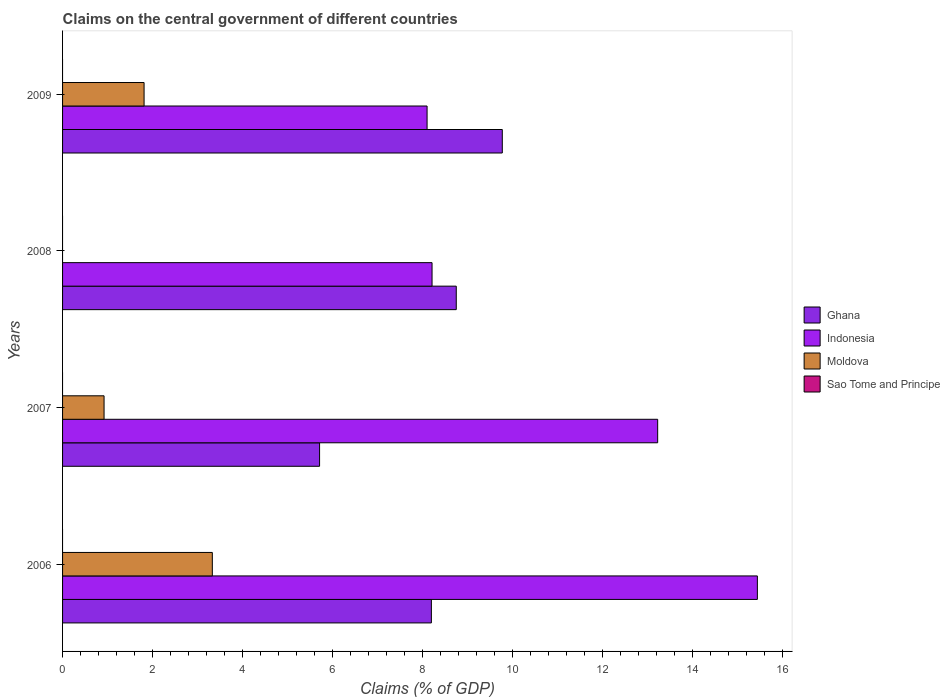How many different coloured bars are there?
Offer a very short reply. 3. How many groups of bars are there?
Your response must be concise. 4. Are the number of bars per tick equal to the number of legend labels?
Make the answer very short. No. Are the number of bars on each tick of the Y-axis equal?
Provide a short and direct response. No. How many bars are there on the 4th tick from the bottom?
Make the answer very short. 3. In how many cases, is the number of bars for a given year not equal to the number of legend labels?
Ensure brevity in your answer.  4. What is the percentage of GDP claimed on the central government in Indonesia in 2007?
Provide a succinct answer. 13.23. Across all years, what is the maximum percentage of GDP claimed on the central government in Indonesia?
Offer a terse response. 15.44. Across all years, what is the minimum percentage of GDP claimed on the central government in Ghana?
Give a very brief answer. 5.71. In which year was the percentage of GDP claimed on the central government in Moldova maximum?
Make the answer very short. 2006. What is the total percentage of GDP claimed on the central government in Indonesia in the graph?
Make the answer very short. 44.98. What is the difference between the percentage of GDP claimed on the central government in Indonesia in 2006 and that in 2007?
Your answer should be compact. 2.22. What is the difference between the percentage of GDP claimed on the central government in Indonesia in 2006 and the percentage of GDP claimed on the central government in Moldova in 2008?
Give a very brief answer. 15.44. In the year 2006, what is the difference between the percentage of GDP claimed on the central government in Ghana and percentage of GDP claimed on the central government in Moldova?
Offer a very short reply. 4.87. What is the ratio of the percentage of GDP claimed on the central government in Indonesia in 2006 to that in 2007?
Give a very brief answer. 1.17. Is the percentage of GDP claimed on the central government in Indonesia in 2006 less than that in 2007?
Your response must be concise. No. What is the difference between the highest and the second highest percentage of GDP claimed on the central government in Indonesia?
Offer a terse response. 2.22. What is the difference between the highest and the lowest percentage of GDP claimed on the central government in Ghana?
Provide a short and direct response. 4.06. Is it the case that in every year, the sum of the percentage of GDP claimed on the central government in Indonesia and percentage of GDP claimed on the central government in Sao Tome and Principe is greater than the sum of percentage of GDP claimed on the central government in Moldova and percentage of GDP claimed on the central government in Ghana?
Ensure brevity in your answer.  Yes. How many bars are there?
Make the answer very short. 11. Are all the bars in the graph horizontal?
Your response must be concise. Yes. How many years are there in the graph?
Your response must be concise. 4. Does the graph contain grids?
Offer a very short reply. No. Where does the legend appear in the graph?
Offer a terse response. Center right. How many legend labels are there?
Keep it short and to the point. 4. What is the title of the graph?
Give a very brief answer. Claims on the central government of different countries. Does "Yemen, Rep." appear as one of the legend labels in the graph?
Give a very brief answer. No. What is the label or title of the X-axis?
Your answer should be compact. Claims (% of GDP). What is the label or title of the Y-axis?
Your answer should be compact. Years. What is the Claims (% of GDP) of Ghana in 2006?
Give a very brief answer. 8.2. What is the Claims (% of GDP) in Indonesia in 2006?
Give a very brief answer. 15.44. What is the Claims (% of GDP) of Moldova in 2006?
Give a very brief answer. 3.33. What is the Claims (% of GDP) of Ghana in 2007?
Give a very brief answer. 5.71. What is the Claims (% of GDP) of Indonesia in 2007?
Your answer should be compact. 13.23. What is the Claims (% of GDP) of Moldova in 2007?
Ensure brevity in your answer.  0.92. What is the Claims (% of GDP) of Sao Tome and Principe in 2007?
Your answer should be very brief. 0. What is the Claims (% of GDP) of Ghana in 2008?
Make the answer very short. 8.75. What is the Claims (% of GDP) of Indonesia in 2008?
Give a very brief answer. 8.21. What is the Claims (% of GDP) of Moldova in 2008?
Provide a succinct answer. 0. What is the Claims (% of GDP) of Ghana in 2009?
Keep it short and to the point. 9.77. What is the Claims (% of GDP) of Indonesia in 2009?
Your answer should be very brief. 8.1. What is the Claims (% of GDP) of Moldova in 2009?
Your response must be concise. 1.81. What is the Claims (% of GDP) in Sao Tome and Principe in 2009?
Your answer should be very brief. 0. Across all years, what is the maximum Claims (% of GDP) of Ghana?
Offer a very short reply. 9.77. Across all years, what is the maximum Claims (% of GDP) in Indonesia?
Your response must be concise. 15.44. Across all years, what is the maximum Claims (% of GDP) of Moldova?
Provide a succinct answer. 3.33. Across all years, what is the minimum Claims (% of GDP) of Ghana?
Give a very brief answer. 5.71. Across all years, what is the minimum Claims (% of GDP) of Indonesia?
Keep it short and to the point. 8.1. What is the total Claims (% of GDP) of Ghana in the graph?
Ensure brevity in your answer.  32.43. What is the total Claims (% of GDP) of Indonesia in the graph?
Offer a terse response. 44.98. What is the total Claims (% of GDP) in Moldova in the graph?
Offer a very short reply. 6.06. What is the total Claims (% of GDP) of Sao Tome and Principe in the graph?
Your answer should be very brief. 0. What is the difference between the Claims (% of GDP) of Ghana in 2006 and that in 2007?
Ensure brevity in your answer.  2.48. What is the difference between the Claims (% of GDP) in Indonesia in 2006 and that in 2007?
Provide a short and direct response. 2.22. What is the difference between the Claims (% of GDP) of Moldova in 2006 and that in 2007?
Offer a very short reply. 2.41. What is the difference between the Claims (% of GDP) in Ghana in 2006 and that in 2008?
Provide a succinct answer. -0.55. What is the difference between the Claims (% of GDP) of Indonesia in 2006 and that in 2008?
Offer a terse response. 7.23. What is the difference between the Claims (% of GDP) in Ghana in 2006 and that in 2009?
Your response must be concise. -1.58. What is the difference between the Claims (% of GDP) in Indonesia in 2006 and that in 2009?
Make the answer very short. 7.34. What is the difference between the Claims (% of GDP) of Moldova in 2006 and that in 2009?
Offer a very short reply. 1.52. What is the difference between the Claims (% of GDP) of Ghana in 2007 and that in 2008?
Offer a very short reply. -3.04. What is the difference between the Claims (% of GDP) of Indonesia in 2007 and that in 2008?
Your answer should be very brief. 5.01. What is the difference between the Claims (% of GDP) of Ghana in 2007 and that in 2009?
Provide a succinct answer. -4.06. What is the difference between the Claims (% of GDP) in Indonesia in 2007 and that in 2009?
Provide a succinct answer. 5.13. What is the difference between the Claims (% of GDP) of Moldova in 2007 and that in 2009?
Ensure brevity in your answer.  -0.89. What is the difference between the Claims (% of GDP) in Ghana in 2008 and that in 2009?
Keep it short and to the point. -1.02. What is the difference between the Claims (% of GDP) in Indonesia in 2008 and that in 2009?
Offer a terse response. 0.11. What is the difference between the Claims (% of GDP) in Ghana in 2006 and the Claims (% of GDP) in Indonesia in 2007?
Ensure brevity in your answer.  -5.03. What is the difference between the Claims (% of GDP) in Ghana in 2006 and the Claims (% of GDP) in Moldova in 2007?
Your response must be concise. 7.27. What is the difference between the Claims (% of GDP) of Indonesia in 2006 and the Claims (% of GDP) of Moldova in 2007?
Offer a very short reply. 14.52. What is the difference between the Claims (% of GDP) in Ghana in 2006 and the Claims (% of GDP) in Indonesia in 2008?
Provide a short and direct response. -0.01. What is the difference between the Claims (% of GDP) of Ghana in 2006 and the Claims (% of GDP) of Indonesia in 2009?
Keep it short and to the point. 0.1. What is the difference between the Claims (% of GDP) of Ghana in 2006 and the Claims (% of GDP) of Moldova in 2009?
Offer a very short reply. 6.39. What is the difference between the Claims (% of GDP) of Indonesia in 2006 and the Claims (% of GDP) of Moldova in 2009?
Offer a terse response. 13.63. What is the difference between the Claims (% of GDP) in Ghana in 2007 and the Claims (% of GDP) in Indonesia in 2008?
Offer a very short reply. -2.5. What is the difference between the Claims (% of GDP) in Ghana in 2007 and the Claims (% of GDP) in Indonesia in 2009?
Offer a terse response. -2.39. What is the difference between the Claims (% of GDP) of Ghana in 2007 and the Claims (% of GDP) of Moldova in 2009?
Provide a succinct answer. 3.9. What is the difference between the Claims (% of GDP) in Indonesia in 2007 and the Claims (% of GDP) in Moldova in 2009?
Your answer should be compact. 11.42. What is the difference between the Claims (% of GDP) in Ghana in 2008 and the Claims (% of GDP) in Indonesia in 2009?
Your response must be concise. 0.65. What is the difference between the Claims (% of GDP) of Ghana in 2008 and the Claims (% of GDP) of Moldova in 2009?
Offer a terse response. 6.94. What is the difference between the Claims (% of GDP) in Indonesia in 2008 and the Claims (% of GDP) in Moldova in 2009?
Your answer should be compact. 6.4. What is the average Claims (% of GDP) of Ghana per year?
Your answer should be compact. 8.11. What is the average Claims (% of GDP) of Indonesia per year?
Make the answer very short. 11.25. What is the average Claims (% of GDP) in Moldova per year?
Make the answer very short. 1.52. In the year 2006, what is the difference between the Claims (% of GDP) of Ghana and Claims (% of GDP) of Indonesia?
Offer a very short reply. -7.25. In the year 2006, what is the difference between the Claims (% of GDP) of Ghana and Claims (% of GDP) of Moldova?
Make the answer very short. 4.87. In the year 2006, what is the difference between the Claims (% of GDP) in Indonesia and Claims (% of GDP) in Moldova?
Provide a succinct answer. 12.11. In the year 2007, what is the difference between the Claims (% of GDP) of Ghana and Claims (% of GDP) of Indonesia?
Provide a short and direct response. -7.51. In the year 2007, what is the difference between the Claims (% of GDP) in Ghana and Claims (% of GDP) in Moldova?
Your response must be concise. 4.79. In the year 2007, what is the difference between the Claims (% of GDP) in Indonesia and Claims (% of GDP) in Moldova?
Offer a terse response. 12.3. In the year 2008, what is the difference between the Claims (% of GDP) in Ghana and Claims (% of GDP) in Indonesia?
Your answer should be compact. 0.54. In the year 2009, what is the difference between the Claims (% of GDP) in Ghana and Claims (% of GDP) in Indonesia?
Give a very brief answer. 1.67. In the year 2009, what is the difference between the Claims (% of GDP) in Ghana and Claims (% of GDP) in Moldova?
Make the answer very short. 7.96. In the year 2009, what is the difference between the Claims (% of GDP) of Indonesia and Claims (% of GDP) of Moldova?
Keep it short and to the point. 6.29. What is the ratio of the Claims (% of GDP) of Ghana in 2006 to that in 2007?
Ensure brevity in your answer.  1.44. What is the ratio of the Claims (% of GDP) of Indonesia in 2006 to that in 2007?
Offer a terse response. 1.17. What is the ratio of the Claims (% of GDP) in Moldova in 2006 to that in 2007?
Your answer should be compact. 3.61. What is the ratio of the Claims (% of GDP) of Ghana in 2006 to that in 2008?
Your answer should be very brief. 0.94. What is the ratio of the Claims (% of GDP) of Indonesia in 2006 to that in 2008?
Provide a succinct answer. 1.88. What is the ratio of the Claims (% of GDP) of Ghana in 2006 to that in 2009?
Keep it short and to the point. 0.84. What is the ratio of the Claims (% of GDP) of Indonesia in 2006 to that in 2009?
Ensure brevity in your answer.  1.91. What is the ratio of the Claims (% of GDP) of Moldova in 2006 to that in 2009?
Your answer should be compact. 1.84. What is the ratio of the Claims (% of GDP) in Ghana in 2007 to that in 2008?
Provide a succinct answer. 0.65. What is the ratio of the Claims (% of GDP) of Indonesia in 2007 to that in 2008?
Provide a short and direct response. 1.61. What is the ratio of the Claims (% of GDP) of Ghana in 2007 to that in 2009?
Keep it short and to the point. 0.58. What is the ratio of the Claims (% of GDP) in Indonesia in 2007 to that in 2009?
Provide a short and direct response. 1.63. What is the ratio of the Claims (% of GDP) in Moldova in 2007 to that in 2009?
Your answer should be compact. 0.51. What is the ratio of the Claims (% of GDP) in Ghana in 2008 to that in 2009?
Provide a succinct answer. 0.9. What is the ratio of the Claims (% of GDP) in Indonesia in 2008 to that in 2009?
Provide a succinct answer. 1.01. What is the difference between the highest and the second highest Claims (% of GDP) of Ghana?
Your answer should be very brief. 1.02. What is the difference between the highest and the second highest Claims (% of GDP) in Indonesia?
Make the answer very short. 2.22. What is the difference between the highest and the second highest Claims (% of GDP) in Moldova?
Make the answer very short. 1.52. What is the difference between the highest and the lowest Claims (% of GDP) in Ghana?
Offer a terse response. 4.06. What is the difference between the highest and the lowest Claims (% of GDP) in Indonesia?
Provide a succinct answer. 7.34. What is the difference between the highest and the lowest Claims (% of GDP) in Moldova?
Your answer should be compact. 3.33. 